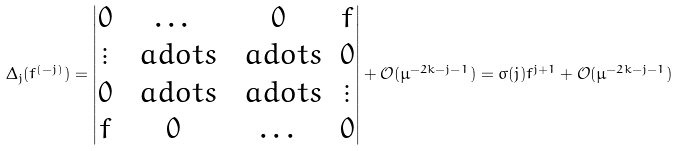Convert formula to latex. <formula><loc_0><loc_0><loc_500><loc_500>\Delta _ { j } ( f ^ { ( - j ) } ) = \left | \begin{matrix} 0 & \dots & 0 & f \\ \vdots & \ a d o t s & \ a d o t s & 0 \\ 0 & \ a d o t s & \ a d o t s & \vdots \\ f & 0 & \dots & 0 \end{matrix} \right | + \mathcal { O } ( \mu ^ { - 2 k - j - 1 } ) = \sigma ( j ) f ^ { j + 1 } + \mathcal { O } ( \mu ^ { - 2 k - j - 1 } )</formula> 